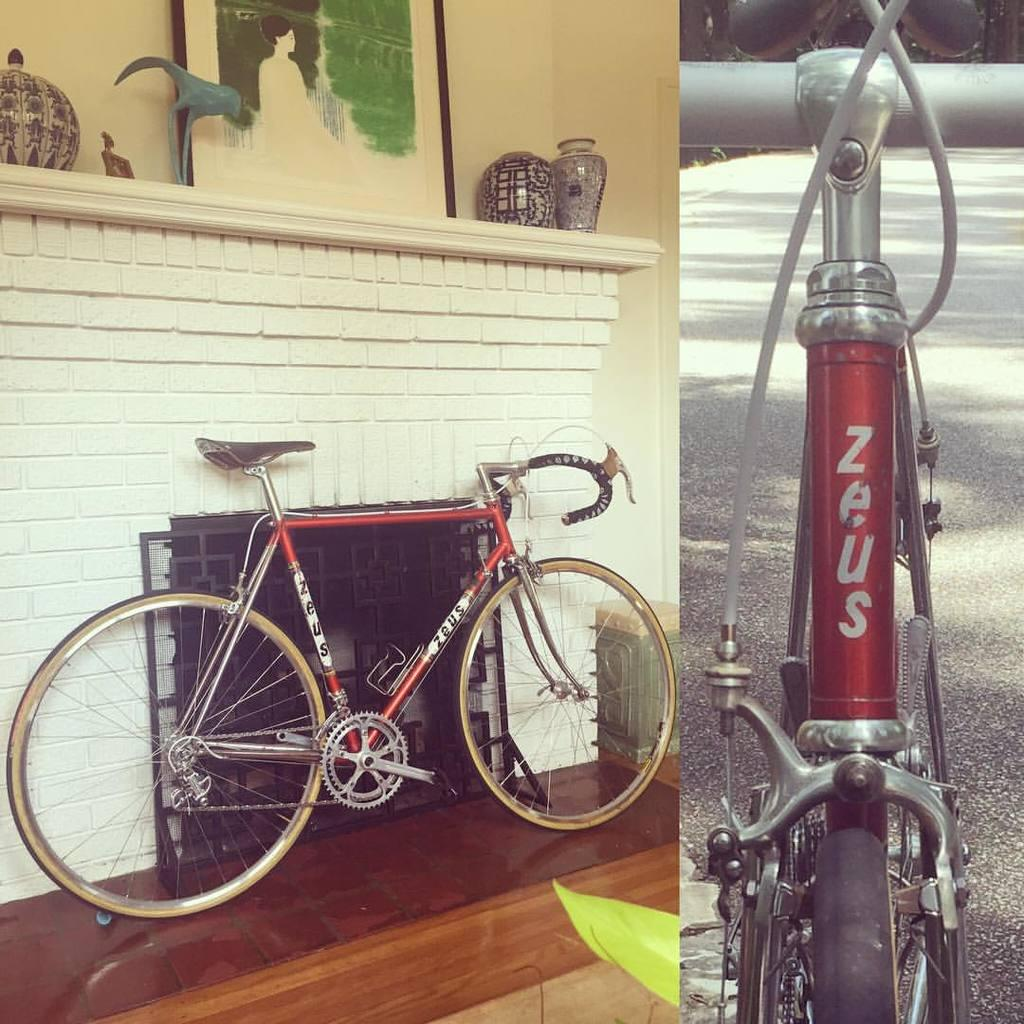What can be seen in the foreground of the image? There are two bicycles in the foreground of the image. What is located behind the bicycles? There is a wall in the image. What type of objects are present on the wall? Ceramic pots are present in the image. What decorative element is on the wall? There is a wall painting in the image. Where might this image have been taken? The image may have been taken on a road. What type of silver material is visible on the bicycles in the image? There is no silver material visible on the bicycles in the image. Can you see any yaks in the image? There are no yaks present in the image. 